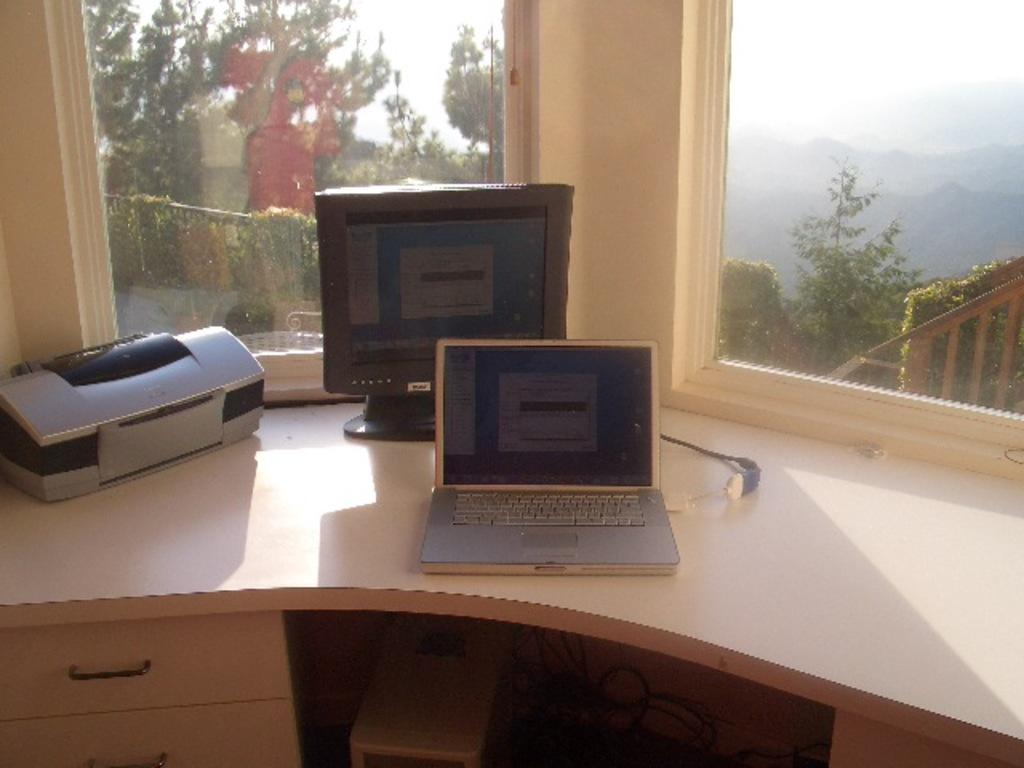What electronic devices are visible in the image? There is a monitor and a laptop in the image. Where are the electronic devices located? Both the monitor and laptop are on a table in the image. What can be seen through the window in the image? Trees are visible through the window in the image. What part of the natural environment is visible in the image? The sky is visible in the image. How many friends are sitting with the grandfather in the image? There is no mention of friends or a grandfather in the image; it only features a monitor, laptop, table, window, trees, and sky. 